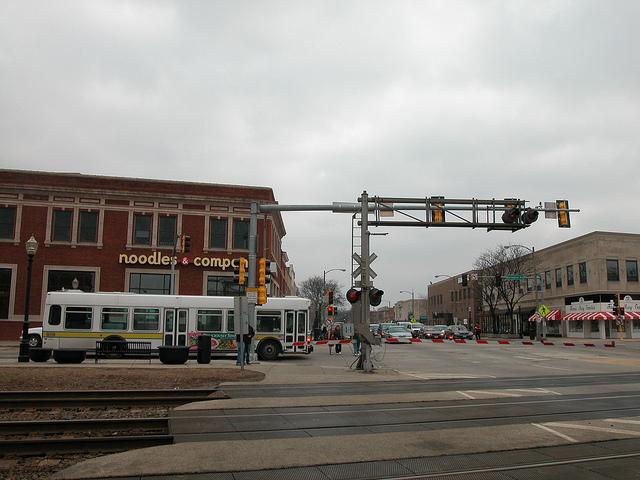Does this bus have only one level?
Answer briefly. Yes. Is the middle light on?
Be succinct. Yes. What is the name of the building in the background?
Quick response, please. Noodles & company. Are the trees green?
Be succinct. No. How many bikes are there?
Answer briefly. 0. What color are the tall buildings?
Keep it brief. Brown. Are there any telephone poles?
Quick response, please. No. Is this a big city?
Short answer required. No. What is the name of the building?
Quick response, please. Noodles & company. What is the name of the restaurant to the left?
Write a very short answer. Noodles & company. In what country was this photo taken?
Be succinct. Usa. What type of bus is this?
Be succinct. City bus. What are the yellow things in the background?
Short answer required. Traffic lights. Is it sunny?
Concise answer only. No. What is something that is sold in this store?
Write a very short answer. Noodles. Is there a tower present in this photo?
Answer briefly. No. What in the street?
Give a very brief answer. Bus. What is the bank on the sign?
Be succinct. Bank of america. Is this a busy street?
Quick response, please. Yes. Have the cars stopped at the light?
Answer briefly. Yes. Is this picture in color?
Short answer required. Yes. What pattern are the awnings on the far right?
Answer briefly. Stripes. Is the building square?
Quick response, please. Yes. What does the giant sign say?
Answer briefly. Noodles & company. Is the day cloudy?
Write a very short answer. Yes. Is this a sightseeing platform?
Answer briefly. No. What is on the track?
Short answer required. Nothing. What time of day is it?
Write a very short answer. Afternoon. How many garbage cans do you see?
Quick response, please. 1. What season is this?
Give a very brief answer. Fall. What crosses the road here?
Be succinct. Train. What color dress is the woman behind the pole wearing?
Keep it brief. Blue. How many floors does the building have?
Give a very brief answer. 2. What kind of cars are being sold at the lot?
Write a very short answer. None. What kind of vehicle is this?
Answer briefly. Bus. What word on the building?
Give a very brief answer. Noodles and company. What color is the truck?
Be succinct. White. What type of transportation is in the photo?
Write a very short answer. Bus. Is there water in this picture?
Quick response, please. No. Are those vehicles parked?
Give a very brief answer. No. How many stories tall is the building on the left?
Quick response, please. 2. What color is the largest vehicle on the street?
Short answer required. White. Is the road crowded?
Be succinct. No. What is in the background?
Give a very brief answer. Cars. How many types of vehicles are in the photo?
Write a very short answer. 2. What vehicle is in this picture?
Quick response, please. Bus. How many vehicles are in view?
Concise answer only. 7. Is there a fence along this track?
Concise answer only. No. Is the school bus at a crosswalk?
Short answer required. No. What colors are the buses?
Answer briefly. White. What shape are the stairs?
Write a very short answer. Square. What color are the trains?
Be succinct. White. How many cars are on the road?
Write a very short answer. 6. Are there safety gates at this railroad crossing?
Write a very short answer. Yes. 